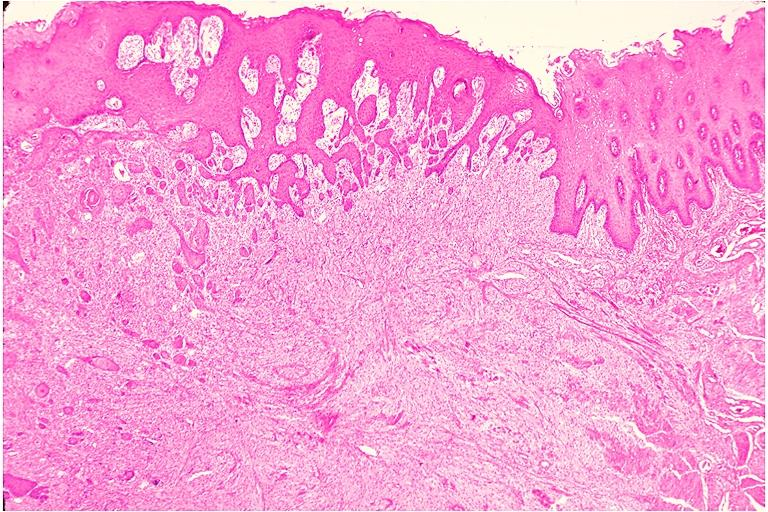does endometritis postpartum show granular cell tumor?
Answer the question using a single word or phrase. No 